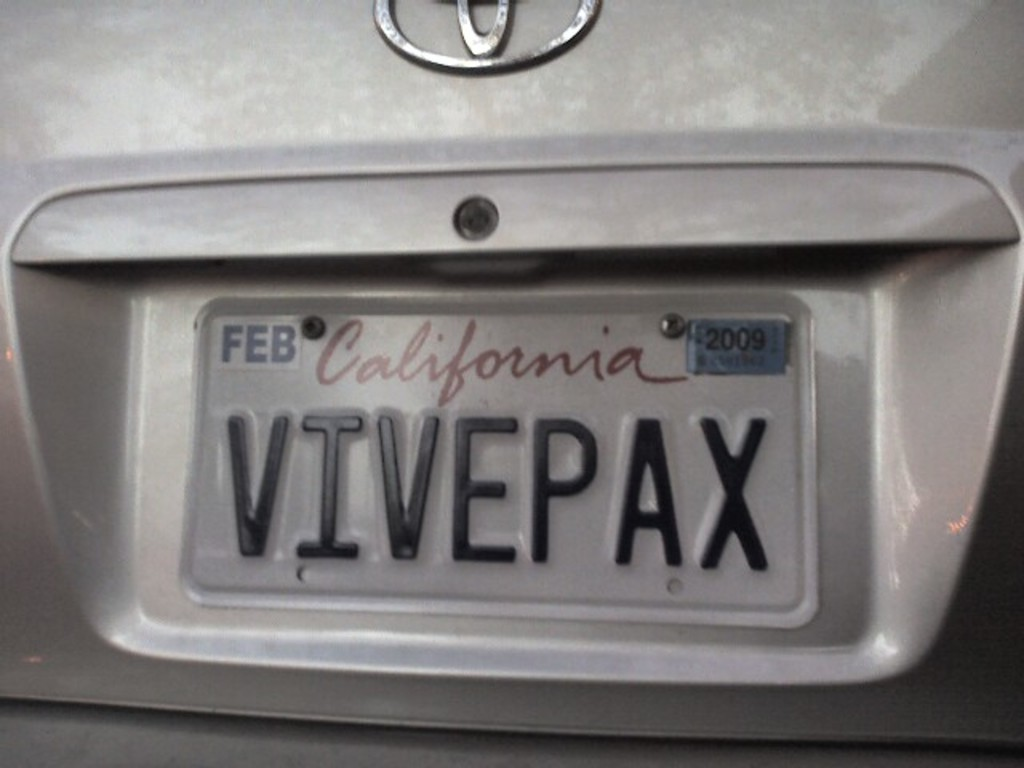What does the license plate suggest about the owner or the car's story? The personalized license plate 'VIVEPAX' could suggest that the owner may value peace or has a particular interest in Latin phrases since 'Pax' translates to 'peace' in Latin. The expired tags might indicate that the car is not frequently used or that the owner has overlooked renewing the vehicle’s registration. 